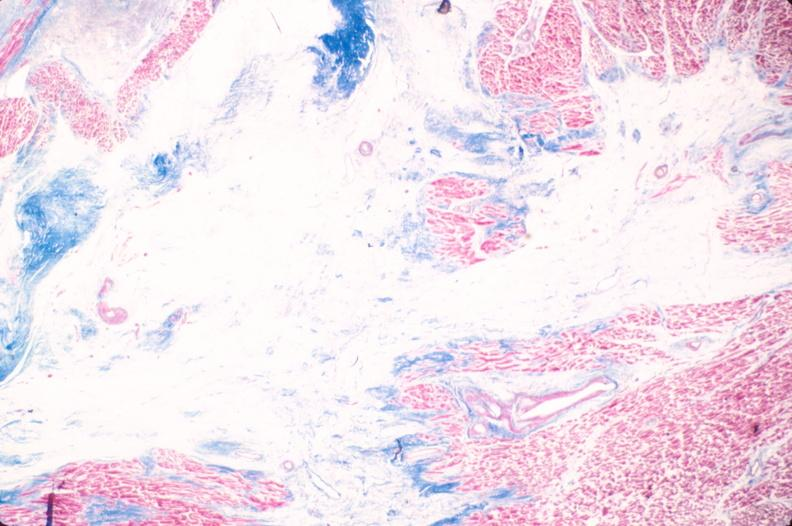s pus in test tube present?
Answer the question using a single word or phrase. No 